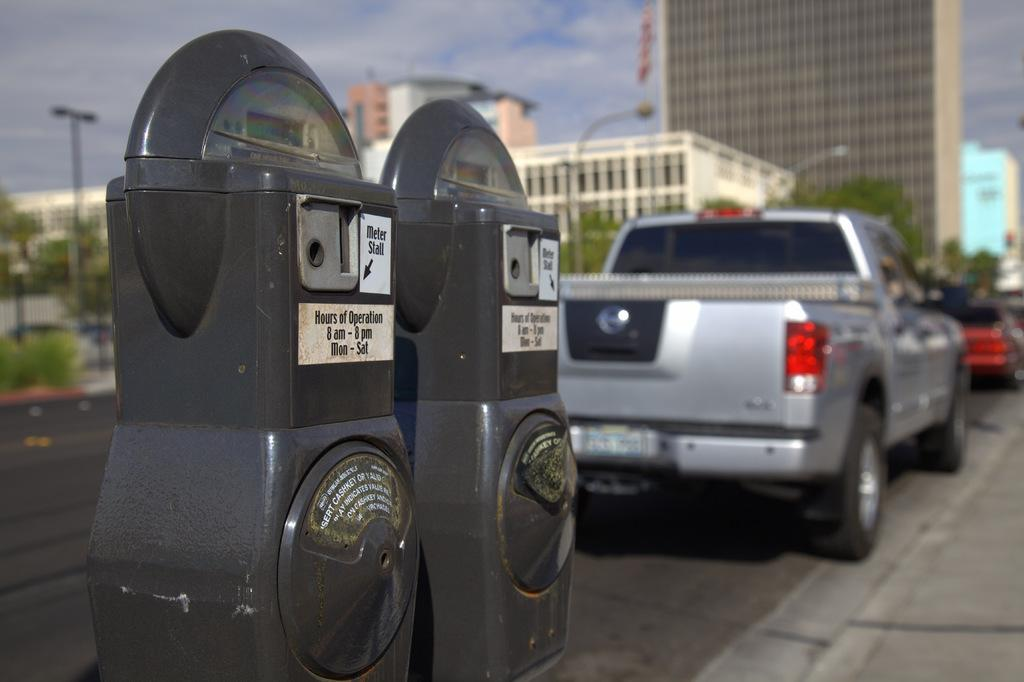<image>
Write a terse but informative summary of the picture. Two meters on the road indicate their hours of operation. 